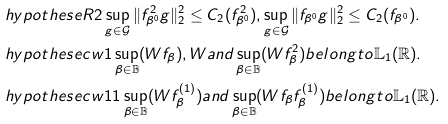Convert formula to latex. <formula><loc_0><loc_0><loc_500><loc_500>& \ h y p o t h e s e { R 2 } \sup _ { g \in \mathcal { G } } \| f _ { \beta ^ { 0 } } ^ { 2 } g \| _ { 2 } ^ { 2 } \leq C _ { 2 } ( f _ { \beta ^ { 0 } } ^ { 2 } ) , \sup _ { g \in \mathcal { G } } \| f _ { \beta ^ { 0 } } g \| _ { 2 } ^ { 2 } \leq C _ { 2 } ( f _ { \beta ^ { 0 } } ) . \\ & \ h y p o t h e s e { c w 1 } \sup _ { \beta \in \mathbb { B } } ( W f _ { \beta } ) , W a n d \sup _ { \beta \in \mathbb { B } } ( W f ^ { 2 } _ { \beta } ) b e l o n g t o \mathbb { L } _ { 1 } ( \mathbb { R } ) . \\ & \ h y p o t h e s e { c w 1 1 } \sup _ { \beta \in \mathbb { B } } ( W f ^ { ( 1 ) } _ { \beta } ) a n d \sup _ { \beta \in \mathbb { B } } ( W f _ { \beta } f ^ { ( 1 ) } _ { \beta } ) b e l o n g t o \mathbb { L } _ { 1 } ( \mathbb { R } ) .</formula> 